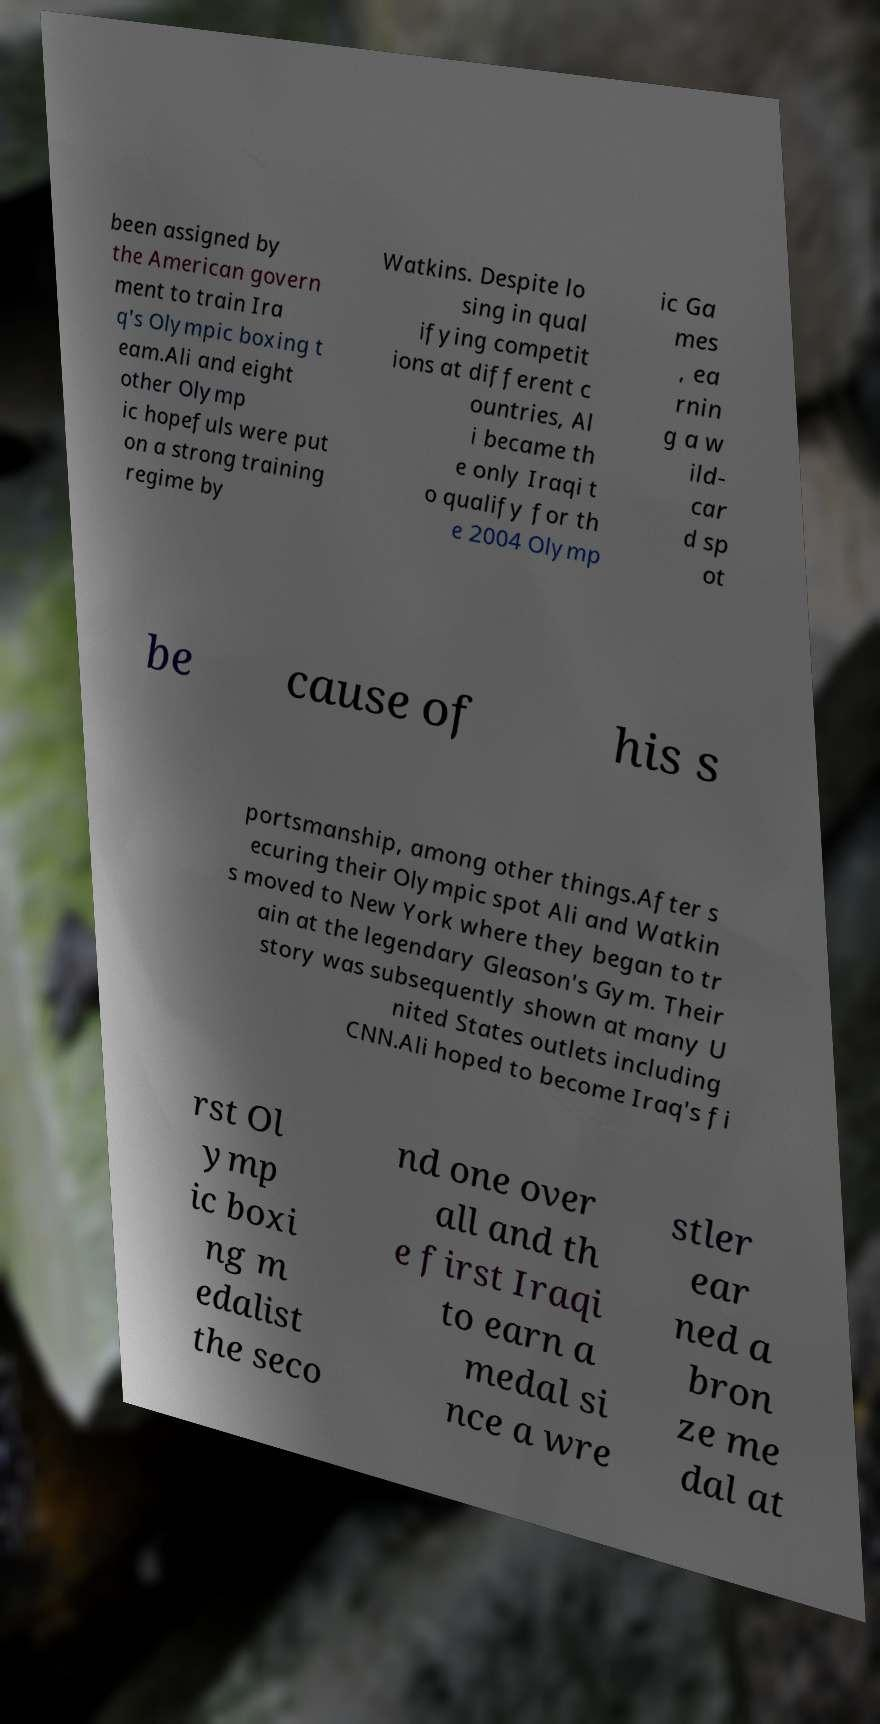Could you extract and type out the text from this image? been assigned by the American govern ment to train Ira q's Olympic boxing t eam.Ali and eight other Olymp ic hopefuls were put on a strong training regime by Watkins. Despite lo sing in qual ifying competit ions at different c ountries, Al i became th e only Iraqi t o qualify for th e 2004 Olymp ic Ga mes , ea rnin g a w ild- car d sp ot be cause of his s portsmanship, among other things.After s ecuring their Olympic spot Ali and Watkin s moved to New York where they began to tr ain at the legendary Gleason's Gym. Their story was subsequently shown at many U nited States outlets including CNN.Ali hoped to become Iraq's fi rst Ol ymp ic boxi ng m edalist the seco nd one over all and th e first Iraqi to earn a medal si nce a wre stler ear ned a bron ze me dal at 